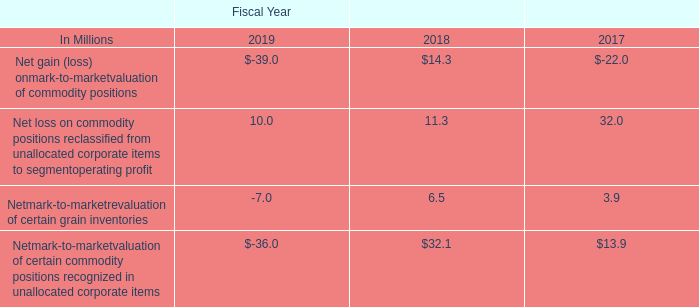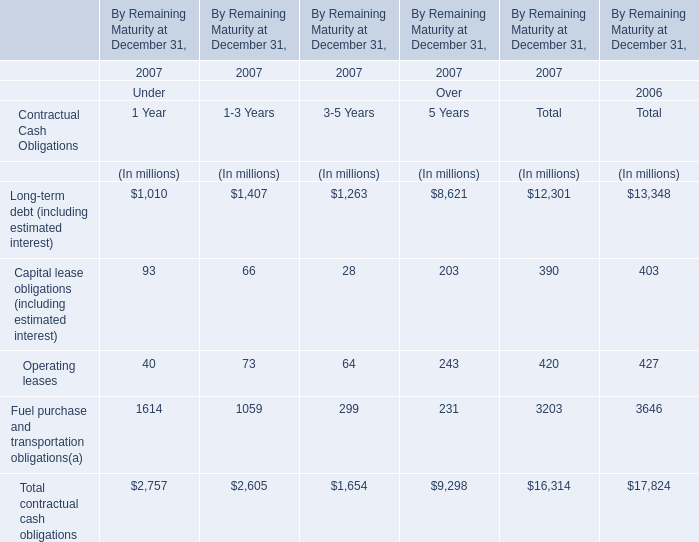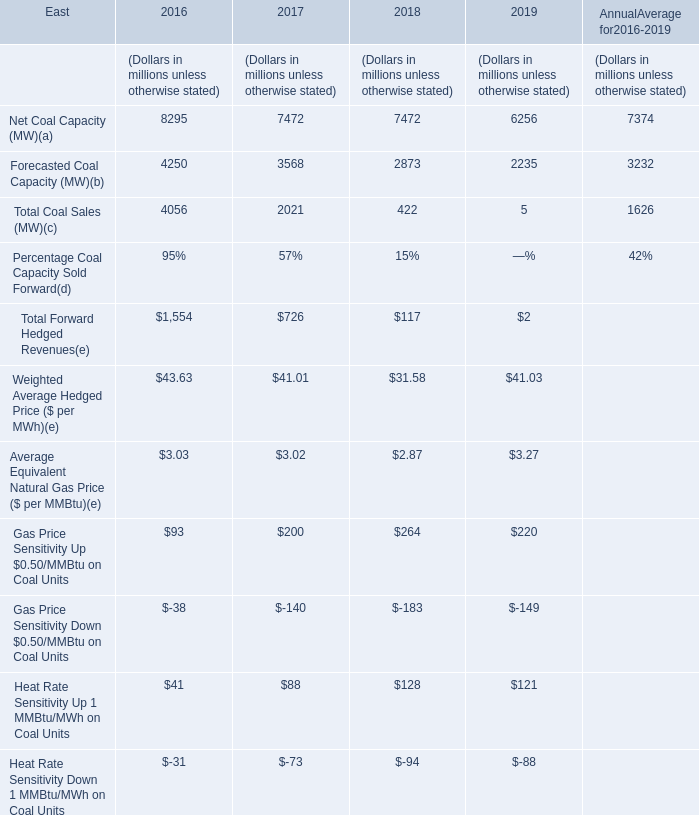Which year is Forecasted Coal Capacity greater than 3500 ? 
Answer: 2016 2017. 